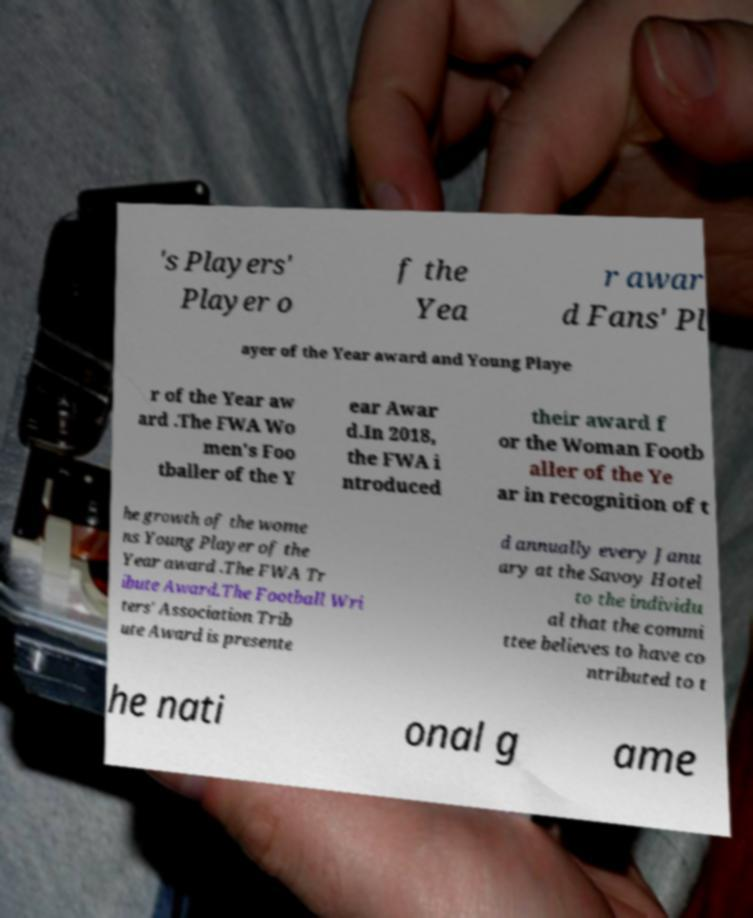Can you accurately transcribe the text from the provided image for me? 's Players' Player o f the Yea r awar d Fans' Pl ayer of the Year award and Young Playe r of the Year aw ard .The FWA Wo men's Foo tballer of the Y ear Awar d.In 2018, the FWA i ntroduced their award f or the Woman Footb aller of the Ye ar in recognition of t he growth of the wome ns Young Player of the Year award .The FWA Tr ibute Award.The Football Wri ters' Association Trib ute Award is presente d annually every Janu ary at the Savoy Hotel to the individu al that the commi ttee believes to have co ntributed to t he nati onal g ame 